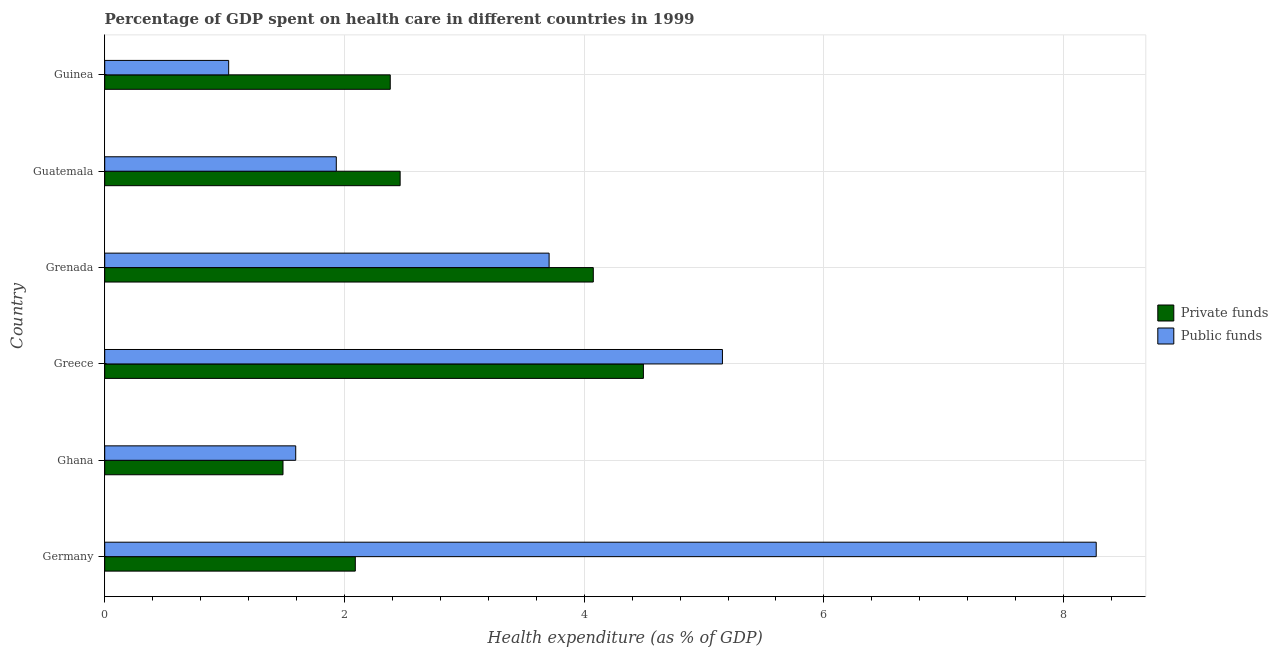How many different coloured bars are there?
Your response must be concise. 2. Are the number of bars per tick equal to the number of legend labels?
Provide a succinct answer. Yes. How many bars are there on the 1st tick from the top?
Your answer should be very brief. 2. How many bars are there on the 4th tick from the bottom?
Ensure brevity in your answer.  2. What is the label of the 1st group of bars from the top?
Keep it short and to the point. Guinea. What is the amount of public funds spent in healthcare in Ghana?
Keep it short and to the point. 1.59. Across all countries, what is the maximum amount of private funds spent in healthcare?
Give a very brief answer. 4.49. Across all countries, what is the minimum amount of private funds spent in healthcare?
Keep it short and to the point. 1.49. In which country was the amount of private funds spent in healthcare maximum?
Give a very brief answer. Greece. In which country was the amount of private funds spent in healthcare minimum?
Ensure brevity in your answer.  Ghana. What is the total amount of private funds spent in healthcare in the graph?
Provide a succinct answer. 16.99. What is the difference between the amount of private funds spent in healthcare in Greece and that in Guatemala?
Offer a very short reply. 2.03. What is the difference between the amount of private funds spent in healthcare in Ghana and the amount of public funds spent in healthcare in Guinea?
Offer a very short reply. 0.45. What is the average amount of public funds spent in healthcare per country?
Your response must be concise. 3.62. What is the difference between the amount of public funds spent in healthcare and amount of private funds spent in healthcare in Guinea?
Provide a short and direct response. -1.35. In how many countries, is the amount of public funds spent in healthcare greater than 6.8 %?
Your answer should be compact. 1. What is the ratio of the amount of private funds spent in healthcare in Germany to that in Ghana?
Offer a terse response. 1.41. Is the difference between the amount of public funds spent in healthcare in Ghana and Guinea greater than the difference between the amount of private funds spent in healthcare in Ghana and Guinea?
Give a very brief answer. Yes. What is the difference between the highest and the second highest amount of public funds spent in healthcare?
Your answer should be very brief. 3.12. What is the difference between the highest and the lowest amount of private funds spent in healthcare?
Your response must be concise. 3.01. In how many countries, is the amount of private funds spent in healthcare greater than the average amount of private funds spent in healthcare taken over all countries?
Offer a terse response. 2. Is the sum of the amount of private funds spent in healthcare in Germany and Grenada greater than the maximum amount of public funds spent in healthcare across all countries?
Ensure brevity in your answer.  No. What does the 2nd bar from the top in Guinea represents?
Ensure brevity in your answer.  Private funds. What does the 2nd bar from the bottom in Guinea represents?
Your answer should be compact. Public funds. How many bars are there?
Provide a short and direct response. 12. Are the values on the major ticks of X-axis written in scientific E-notation?
Provide a short and direct response. No. Does the graph contain any zero values?
Keep it short and to the point. No. Does the graph contain grids?
Provide a succinct answer. Yes. Where does the legend appear in the graph?
Your answer should be very brief. Center right. What is the title of the graph?
Offer a very short reply. Percentage of GDP spent on health care in different countries in 1999. Does "Food and tobacco" appear as one of the legend labels in the graph?
Your response must be concise. No. What is the label or title of the X-axis?
Your answer should be compact. Health expenditure (as % of GDP). What is the label or title of the Y-axis?
Your answer should be compact. Country. What is the Health expenditure (as % of GDP) in Private funds in Germany?
Offer a terse response. 2.09. What is the Health expenditure (as % of GDP) in Public funds in Germany?
Provide a succinct answer. 8.27. What is the Health expenditure (as % of GDP) of Private funds in Ghana?
Provide a succinct answer. 1.49. What is the Health expenditure (as % of GDP) in Public funds in Ghana?
Provide a short and direct response. 1.59. What is the Health expenditure (as % of GDP) of Private funds in Greece?
Keep it short and to the point. 4.49. What is the Health expenditure (as % of GDP) in Public funds in Greece?
Offer a terse response. 5.15. What is the Health expenditure (as % of GDP) in Private funds in Grenada?
Your answer should be very brief. 4.08. What is the Health expenditure (as % of GDP) in Public funds in Grenada?
Offer a very short reply. 3.71. What is the Health expenditure (as % of GDP) of Private funds in Guatemala?
Your answer should be compact. 2.46. What is the Health expenditure (as % of GDP) of Public funds in Guatemala?
Provide a short and direct response. 1.93. What is the Health expenditure (as % of GDP) of Private funds in Guinea?
Give a very brief answer. 2.38. What is the Health expenditure (as % of GDP) of Public funds in Guinea?
Offer a very short reply. 1.03. Across all countries, what is the maximum Health expenditure (as % of GDP) of Private funds?
Give a very brief answer. 4.49. Across all countries, what is the maximum Health expenditure (as % of GDP) in Public funds?
Your answer should be compact. 8.27. Across all countries, what is the minimum Health expenditure (as % of GDP) of Private funds?
Your answer should be compact. 1.49. Across all countries, what is the minimum Health expenditure (as % of GDP) of Public funds?
Provide a short and direct response. 1.03. What is the total Health expenditure (as % of GDP) in Private funds in the graph?
Your answer should be compact. 16.99. What is the total Health expenditure (as % of GDP) of Public funds in the graph?
Your answer should be very brief. 21.69. What is the difference between the Health expenditure (as % of GDP) of Private funds in Germany and that in Ghana?
Your answer should be compact. 0.6. What is the difference between the Health expenditure (as % of GDP) in Public funds in Germany and that in Ghana?
Your response must be concise. 6.68. What is the difference between the Health expenditure (as % of GDP) in Private funds in Germany and that in Greece?
Your answer should be compact. -2.4. What is the difference between the Health expenditure (as % of GDP) of Public funds in Germany and that in Greece?
Make the answer very short. 3.12. What is the difference between the Health expenditure (as % of GDP) of Private funds in Germany and that in Grenada?
Your answer should be very brief. -1.99. What is the difference between the Health expenditure (as % of GDP) in Public funds in Germany and that in Grenada?
Your response must be concise. 4.56. What is the difference between the Health expenditure (as % of GDP) of Private funds in Germany and that in Guatemala?
Offer a very short reply. -0.37. What is the difference between the Health expenditure (as % of GDP) of Public funds in Germany and that in Guatemala?
Give a very brief answer. 6.34. What is the difference between the Health expenditure (as % of GDP) in Private funds in Germany and that in Guinea?
Keep it short and to the point. -0.29. What is the difference between the Health expenditure (as % of GDP) of Public funds in Germany and that in Guinea?
Ensure brevity in your answer.  7.24. What is the difference between the Health expenditure (as % of GDP) of Private funds in Ghana and that in Greece?
Offer a very short reply. -3.01. What is the difference between the Health expenditure (as % of GDP) in Public funds in Ghana and that in Greece?
Offer a very short reply. -3.56. What is the difference between the Health expenditure (as % of GDP) in Private funds in Ghana and that in Grenada?
Offer a terse response. -2.59. What is the difference between the Health expenditure (as % of GDP) of Public funds in Ghana and that in Grenada?
Give a very brief answer. -2.11. What is the difference between the Health expenditure (as % of GDP) of Private funds in Ghana and that in Guatemala?
Provide a succinct answer. -0.98. What is the difference between the Health expenditure (as % of GDP) of Public funds in Ghana and that in Guatemala?
Provide a succinct answer. -0.34. What is the difference between the Health expenditure (as % of GDP) in Private funds in Ghana and that in Guinea?
Make the answer very short. -0.89. What is the difference between the Health expenditure (as % of GDP) in Public funds in Ghana and that in Guinea?
Provide a succinct answer. 0.56. What is the difference between the Health expenditure (as % of GDP) in Private funds in Greece and that in Grenada?
Give a very brief answer. 0.42. What is the difference between the Health expenditure (as % of GDP) of Public funds in Greece and that in Grenada?
Offer a terse response. 1.45. What is the difference between the Health expenditure (as % of GDP) in Private funds in Greece and that in Guatemala?
Provide a short and direct response. 2.03. What is the difference between the Health expenditure (as % of GDP) of Public funds in Greece and that in Guatemala?
Offer a very short reply. 3.22. What is the difference between the Health expenditure (as % of GDP) in Private funds in Greece and that in Guinea?
Provide a short and direct response. 2.11. What is the difference between the Health expenditure (as % of GDP) in Public funds in Greece and that in Guinea?
Ensure brevity in your answer.  4.12. What is the difference between the Health expenditure (as % of GDP) of Private funds in Grenada and that in Guatemala?
Your response must be concise. 1.61. What is the difference between the Health expenditure (as % of GDP) of Public funds in Grenada and that in Guatemala?
Your answer should be compact. 1.78. What is the difference between the Health expenditure (as % of GDP) of Private funds in Grenada and that in Guinea?
Ensure brevity in your answer.  1.69. What is the difference between the Health expenditure (as % of GDP) in Public funds in Grenada and that in Guinea?
Give a very brief answer. 2.67. What is the difference between the Health expenditure (as % of GDP) of Private funds in Guatemala and that in Guinea?
Keep it short and to the point. 0.08. What is the difference between the Health expenditure (as % of GDP) of Public funds in Guatemala and that in Guinea?
Provide a short and direct response. 0.9. What is the difference between the Health expenditure (as % of GDP) of Private funds in Germany and the Health expenditure (as % of GDP) of Public funds in Ghana?
Provide a succinct answer. 0.5. What is the difference between the Health expenditure (as % of GDP) of Private funds in Germany and the Health expenditure (as % of GDP) of Public funds in Greece?
Provide a succinct answer. -3.06. What is the difference between the Health expenditure (as % of GDP) of Private funds in Germany and the Health expenditure (as % of GDP) of Public funds in Grenada?
Provide a short and direct response. -1.62. What is the difference between the Health expenditure (as % of GDP) of Private funds in Germany and the Health expenditure (as % of GDP) of Public funds in Guatemala?
Provide a short and direct response. 0.16. What is the difference between the Health expenditure (as % of GDP) in Private funds in Germany and the Health expenditure (as % of GDP) in Public funds in Guinea?
Offer a very short reply. 1.06. What is the difference between the Health expenditure (as % of GDP) of Private funds in Ghana and the Health expenditure (as % of GDP) of Public funds in Greece?
Offer a very short reply. -3.67. What is the difference between the Health expenditure (as % of GDP) of Private funds in Ghana and the Health expenditure (as % of GDP) of Public funds in Grenada?
Offer a very short reply. -2.22. What is the difference between the Health expenditure (as % of GDP) in Private funds in Ghana and the Health expenditure (as % of GDP) in Public funds in Guatemala?
Keep it short and to the point. -0.44. What is the difference between the Health expenditure (as % of GDP) of Private funds in Ghana and the Health expenditure (as % of GDP) of Public funds in Guinea?
Provide a succinct answer. 0.45. What is the difference between the Health expenditure (as % of GDP) of Private funds in Greece and the Health expenditure (as % of GDP) of Public funds in Grenada?
Your answer should be very brief. 0.79. What is the difference between the Health expenditure (as % of GDP) of Private funds in Greece and the Health expenditure (as % of GDP) of Public funds in Guatemala?
Offer a very short reply. 2.56. What is the difference between the Health expenditure (as % of GDP) of Private funds in Greece and the Health expenditure (as % of GDP) of Public funds in Guinea?
Make the answer very short. 3.46. What is the difference between the Health expenditure (as % of GDP) in Private funds in Grenada and the Health expenditure (as % of GDP) in Public funds in Guatemala?
Provide a short and direct response. 2.14. What is the difference between the Health expenditure (as % of GDP) in Private funds in Grenada and the Health expenditure (as % of GDP) in Public funds in Guinea?
Your answer should be compact. 3.04. What is the difference between the Health expenditure (as % of GDP) in Private funds in Guatemala and the Health expenditure (as % of GDP) in Public funds in Guinea?
Your answer should be compact. 1.43. What is the average Health expenditure (as % of GDP) of Private funds per country?
Provide a short and direct response. 2.83. What is the average Health expenditure (as % of GDP) of Public funds per country?
Ensure brevity in your answer.  3.62. What is the difference between the Health expenditure (as % of GDP) in Private funds and Health expenditure (as % of GDP) in Public funds in Germany?
Your answer should be compact. -6.18. What is the difference between the Health expenditure (as % of GDP) of Private funds and Health expenditure (as % of GDP) of Public funds in Ghana?
Give a very brief answer. -0.11. What is the difference between the Health expenditure (as % of GDP) of Private funds and Health expenditure (as % of GDP) of Public funds in Greece?
Keep it short and to the point. -0.66. What is the difference between the Health expenditure (as % of GDP) in Private funds and Health expenditure (as % of GDP) in Public funds in Grenada?
Provide a succinct answer. 0.37. What is the difference between the Health expenditure (as % of GDP) in Private funds and Health expenditure (as % of GDP) in Public funds in Guatemala?
Offer a terse response. 0.53. What is the difference between the Health expenditure (as % of GDP) in Private funds and Health expenditure (as % of GDP) in Public funds in Guinea?
Provide a succinct answer. 1.35. What is the ratio of the Health expenditure (as % of GDP) in Private funds in Germany to that in Ghana?
Make the answer very short. 1.41. What is the ratio of the Health expenditure (as % of GDP) in Public funds in Germany to that in Ghana?
Your answer should be very brief. 5.19. What is the ratio of the Health expenditure (as % of GDP) in Private funds in Germany to that in Greece?
Keep it short and to the point. 0.47. What is the ratio of the Health expenditure (as % of GDP) of Public funds in Germany to that in Greece?
Keep it short and to the point. 1.61. What is the ratio of the Health expenditure (as % of GDP) of Private funds in Germany to that in Grenada?
Give a very brief answer. 0.51. What is the ratio of the Health expenditure (as % of GDP) in Public funds in Germany to that in Grenada?
Offer a terse response. 2.23. What is the ratio of the Health expenditure (as % of GDP) in Private funds in Germany to that in Guatemala?
Provide a succinct answer. 0.85. What is the ratio of the Health expenditure (as % of GDP) of Public funds in Germany to that in Guatemala?
Give a very brief answer. 4.28. What is the ratio of the Health expenditure (as % of GDP) of Private funds in Germany to that in Guinea?
Your response must be concise. 0.88. What is the ratio of the Health expenditure (as % of GDP) in Public funds in Germany to that in Guinea?
Ensure brevity in your answer.  8. What is the ratio of the Health expenditure (as % of GDP) in Private funds in Ghana to that in Greece?
Your response must be concise. 0.33. What is the ratio of the Health expenditure (as % of GDP) in Public funds in Ghana to that in Greece?
Provide a short and direct response. 0.31. What is the ratio of the Health expenditure (as % of GDP) in Private funds in Ghana to that in Grenada?
Your answer should be very brief. 0.36. What is the ratio of the Health expenditure (as % of GDP) in Public funds in Ghana to that in Grenada?
Offer a terse response. 0.43. What is the ratio of the Health expenditure (as % of GDP) in Private funds in Ghana to that in Guatemala?
Ensure brevity in your answer.  0.6. What is the ratio of the Health expenditure (as % of GDP) in Public funds in Ghana to that in Guatemala?
Make the answer very short. 0.82. What is the ratio of the Health expenditure (as % of GDP) of Private funds in Ghana to that in Guinea?
Provide a succinct answer. 0.62. What is the ratio of the Health expenditure (as % of GDP) of Public funds in Ghana to that in Guinea?
Your answer should be very brief. 1.54. What is the ratio of the Health expenditure (as % of GDP) of Private funds in Greece to that in Grenada?
Provide a short and direct response. 1.1. What is the ratio of the Health expenditure (as % of GDP) in Public funds in Greece to that in Grenada?
Make the answer very short. 1.39. What is the ratio of the Health expenditure (as % of GDP) in Private funds in Greece to that in Guatemala?
Your answer should be compact. 1.82. What is the ratio of the Health expenditure (as % of GDP) in Public funds in Greece to that in Guatemala?
Offer a terse response. 2.67. What is the ratio of the Health expenditure (as % of GDP) in Private funds in Greece to that in Guinea?
Your response must be concise. 1.89. What is the ratio of the Health expenditure (as % of GDP) in Public funds in Greece to that in Guinea?
Provide a succinct answer. 4.98. What is the ratio of the Health expenditure (as % of GDP) in Private funds in Grenada to that in Guatemala?
Provide a succinct answer. 1.65. What is the ratio of the Health expenditure (as % of GDP) of Public funds in Grenada to that in Guatemala?
Offer a terse response. 1.92. What is the ratio of the Health expenditure (as % of GDP) in Private funds in Grenada to that in Guinea?
Give a very brief answer. 1.71. What is the ratio of the Health expenditure (as % of GDP) of Public funds in Grenada to that in Guinea?
Provide a short and direct response. 3.59. What is the ratio of the Health expenditure (as % of GDP) in Private funds in Guatemala to that in Guinea?
Make the answer very short. 1.03. What is the ratio of the Health expenditure (as % of GDP) of Public funds in Guatemala to that in Guinea?
Provide a succinct answer. 1.87. What is the difference between the highest and the second highest Health expenditure (as % of GDP) of Private funds?
Provide a succinct answer. 0.42. What is the difference between the highest and the second highest Health expenditure (as % of GDP) of Public funds?
Ensure brevity in your answer.  3.12. What is the difference between the highest and the lowest Health expenditure (as % of GDP) of Private funds?
Keep it short and to the point. 3.01. What is the difference between the highest and the lowest Health expenditure (as % of GDP) of Public funds?
Offer a terse response. 7.24. 